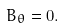Convert formula to latex. <formula><loc_0><loc_0><loc_500><loc_500>B _ { \theta } = 0 .</formula> 